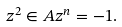Convert formula to latex. <formula><loc_0><loc_0><loc_500><loc_500>z ^ { 2 } \in A z ^ { n } = - 1 .</formula> 